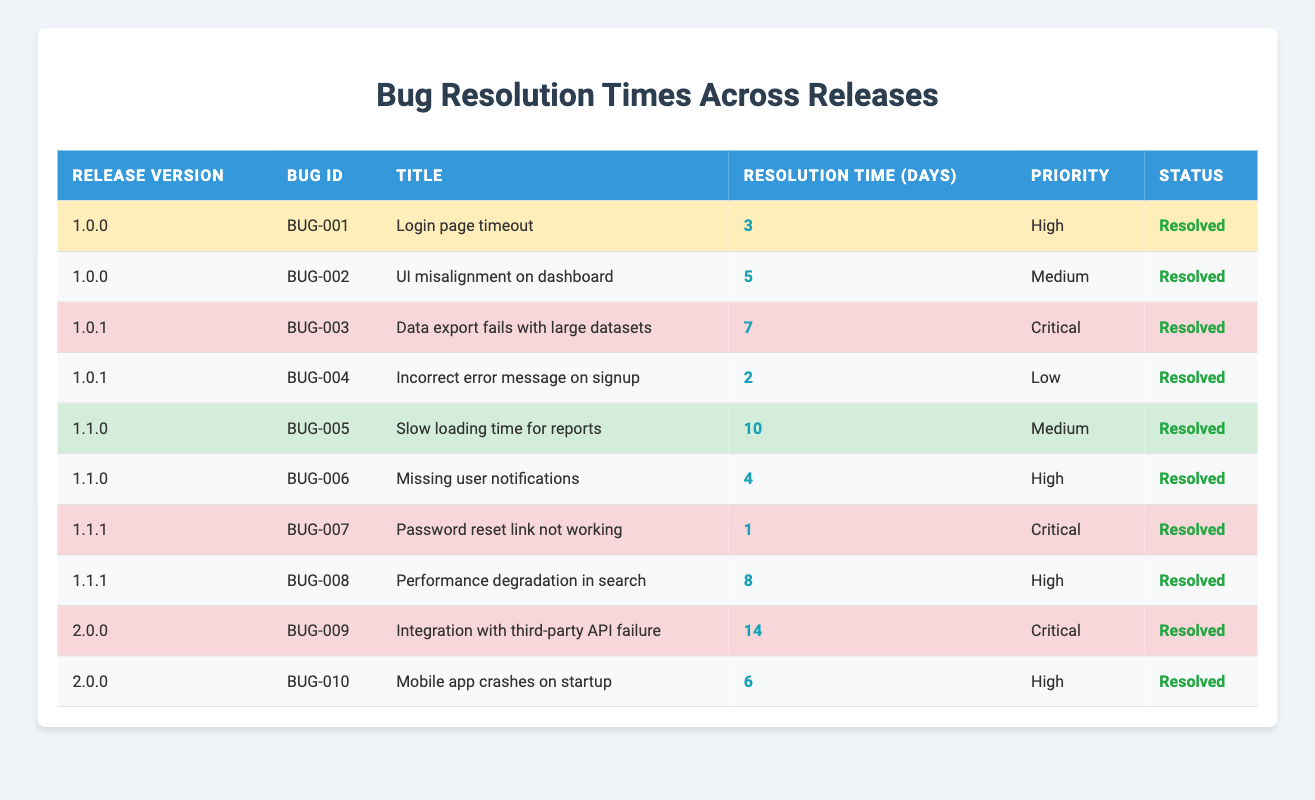What is the resolution time for bug ID BUG-005? The table shows that the resolution time for bug ID BUG-005 under release version 1.1.0 is 10 days.
Answer: 10 How many bugs were resolved in release version 1.0.0? The table lists two bugs (BUG-001 and BUG-002) under release version 1.0.0, indicating that two bugs were resolved in this release.
Answer: 2 What is the priority of the bug with the longest resolution time? The table indicates that the bug with the longest resolution time (14 days) is BUG-009 with a priority of Critical.
Answer: Critical Which release version had the fewest number of resolved bugs? The table shows that release version 1.0.0 has two bugs resolved, 1.0.1 has two, 1.1.0 has two, 1.1.1 has two, and 2.0.0 has two as well. All listed versions have the same number of resolved bugs, which is two.
Answer: All have the same number (2) What is the average resolution time for bugs in release version 1.1.0? The resolution times for bugs in release version 1.1.0 are 10 days (BUG-005) and 4 days (BUG-006). Summing these gives 14 days, and dividing by 2 (the number of bugs) gives an average resolution time of 7 days.
Answer: 7 Is there a bug with a resolution time of 0 days listed in the table? The table lists all resolution times as positive numbers, with the lowest being 1 day for BUG-007, indicating there is no bug with a resolution time of 0 days.
Answer: No How many bugs with a priority of High were resolved in total? Upon counting the entries labeled as High in the priority column, we find there are four bugs (BUG-001, BUG-006, BUG-008, and BUG-010) listed as High priority, hence, four bugs were resolved with this priority.
Answer: 4 What is the total resolution time for all bugs marked as Critical? The resolution times for Critical bugs are 7 days (BUG-003), 1 day (BUG-007), and 14 days (BUG-009). Summing these gives a total of 22 days for bugs marked as Critical.
Answer: 22 Which bug had the shortest resolution time and what was it? The table shows that the bug with the shortest resolution time is BUG-007 with 1 day, making it the quickest resolution time among all listed bugs.
Answer: BUG-007, 1 day How do the resolution times of bugs in version 2.0.0 compare to those in version 1.1.1? For version 2.0.0, the resolution times are 14 days (BUG-009) and 6 days (BUG-010), totaling 20 days. In contrast, for version 1.1.1, the times are 1 day (BUG-007) and 8 days (BUG-008), totaling 9 days. Therefore, bugs in version 2.0.0 took longer on average to resolve than those in version 1.1.1.
Answer: 2.0.0 had longer times (20 days vs. 9 days) 